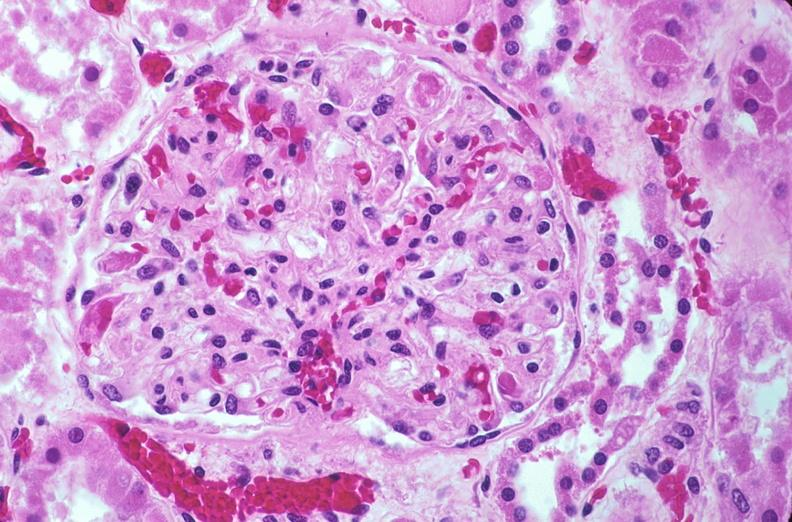how is kidney , microthrombi , disseminated coagulation?
Answer the question using a single word or phrase. Intravascular 